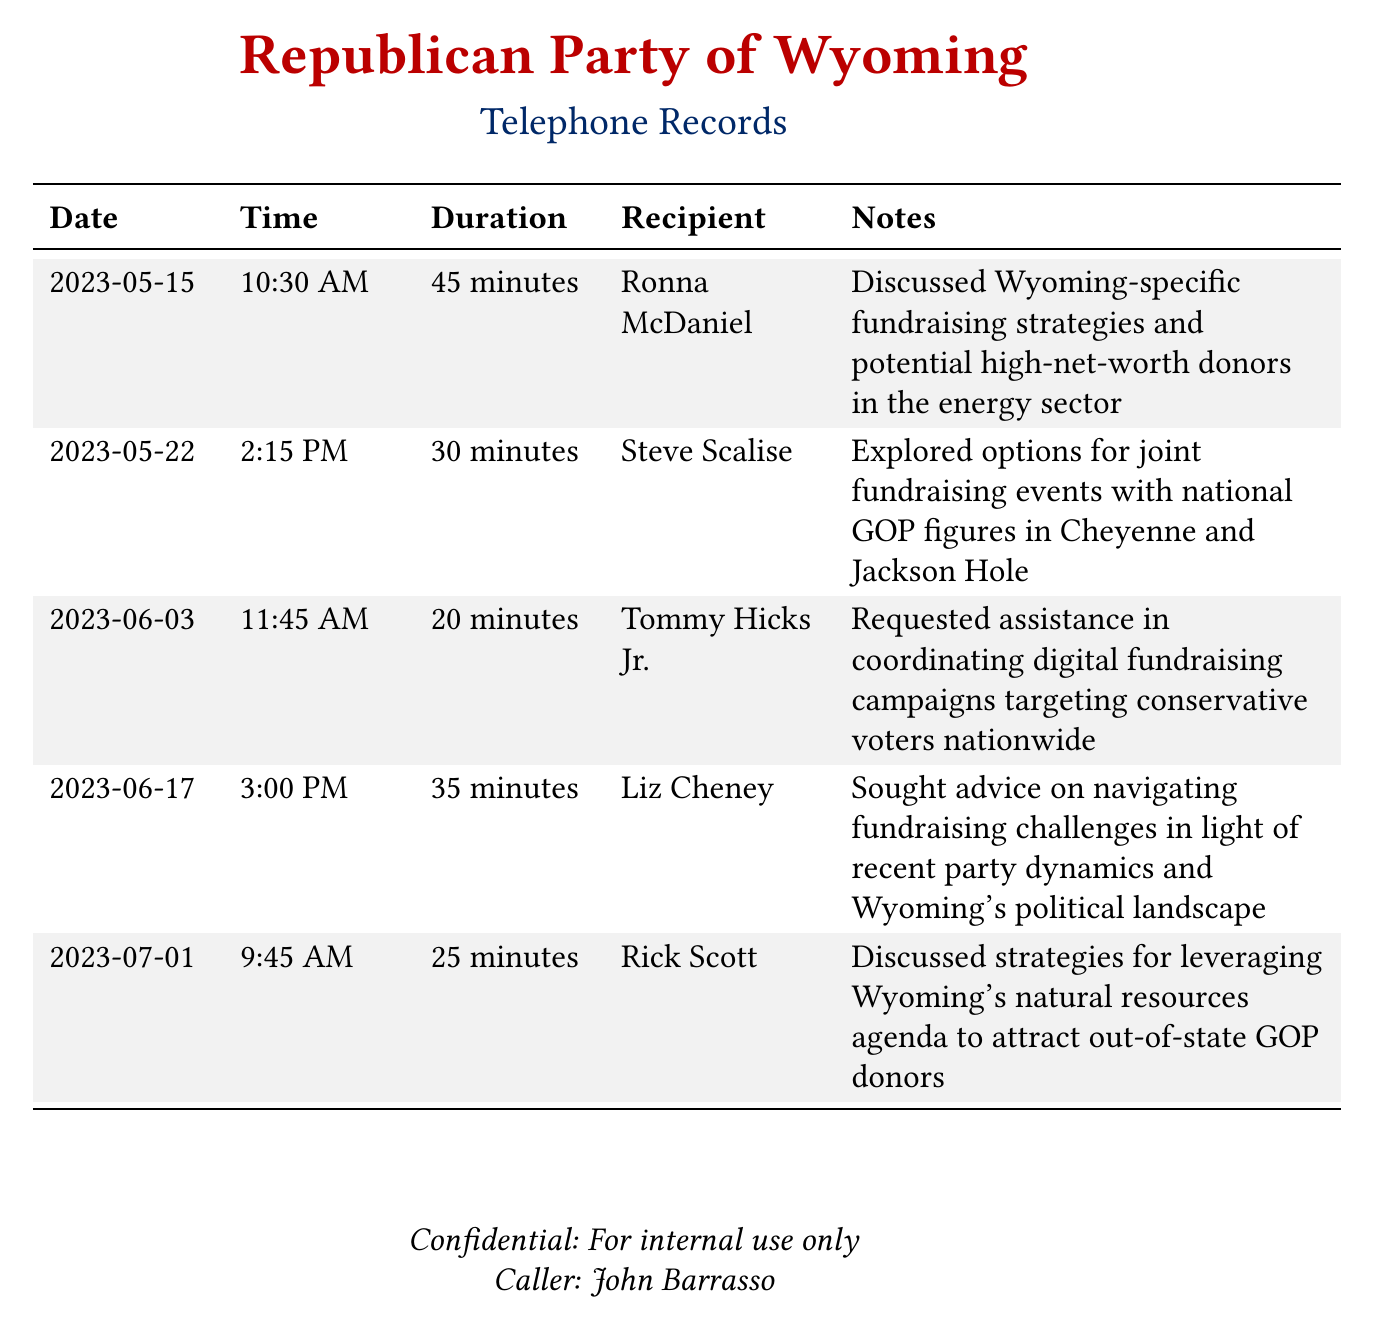What date was the call to Ronna McDaniel? The date of the call can be found in the records under the "Date" column next to her name.
Answer: 2023-05-15 How long was the conversation with Steve Scalise? The duration of the conversation is listed in the "Duration" column corresponding to Steve Scalise.
Answer: 30 minutes Who was advised on fundraising challenges by Liz Cheney? The "Recipient" column identifies the person who spoke to Liz Cheney during the call.
Answer: Liz Cheney What strategy was discussed with Rick Scott? The notes related to Rick Scott provide details about the fundraising strategy discussed.
Answer: Leveraging Wyoming's natural resources agenda How many calls were made in June? By counting the dates listed in June under the "Date" column, the number of calls can be determined.
Answer: 2 calls Which area did the fundraising strategies focus on during the call with Ronna McDaniel? The specific area discussed in the notes about the call provides the context for the strategies focused on.
Answer: Energy sector What is the total duration of calls made to Tommy Hicks Jr. and Rick Scott? By adding the durations from the two calls, the total can be calculated.
Answer: 45 minutes What is the title of the document? The title can be found at the top of the document stating its content.
Answer: Telephone Records Who made the calls documented? The bottom of the document specifies the caller's identity.
Answer: John Barrasso 